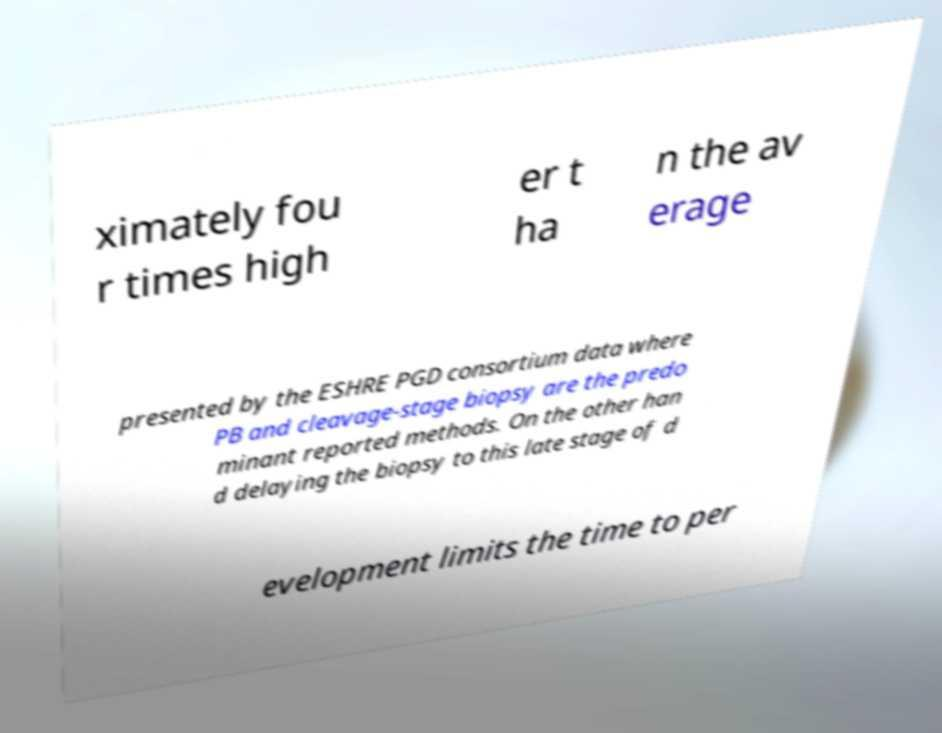For documentation purposes, I need the text within this image transcribed. Could you provide that? ximately fou r times high er t ha n the av erage presented by the ESHRE PGD consortium data where PB and cleavage-stage biopsy are the predo minant reported methods. On the other han d delaying the biopsy to this late stage of d evelopment limits the time to per 